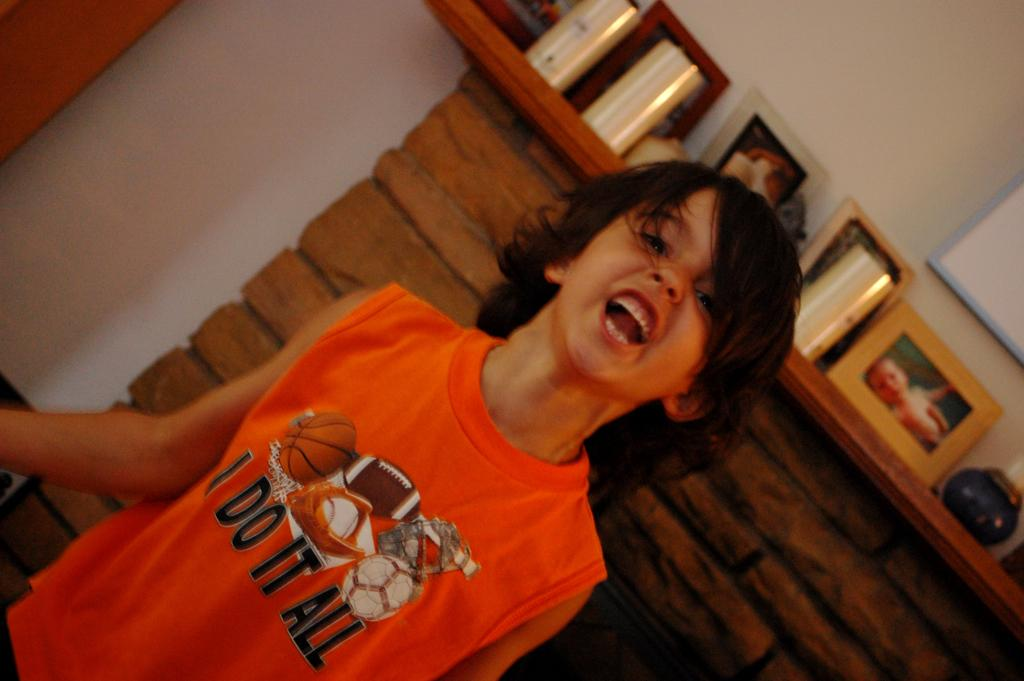Provide a one-sentence caption for the provided image. Little boy standing in front of a fireplace yelling wearing a I do it all shirt. 